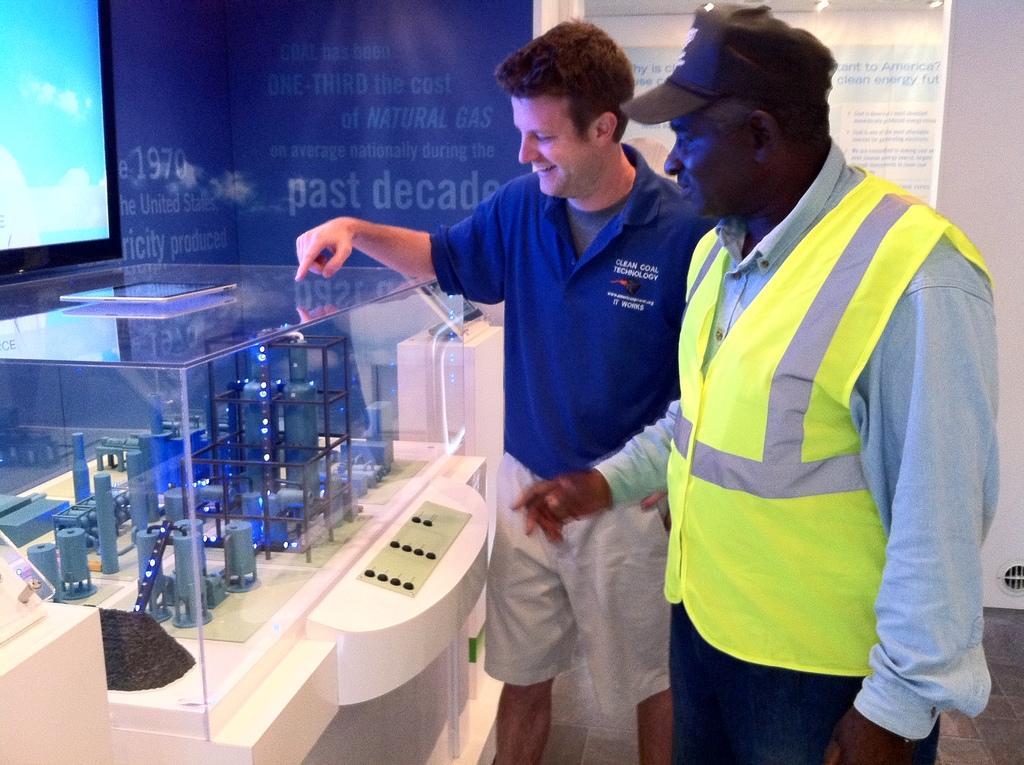Can you describe this image briefly? In this picture we can see two men are standing, on the left side we can see a glass, it looks like a miniature on the left side, we can also see a screen, in the background there is a chart, we can see some text on the chart. 